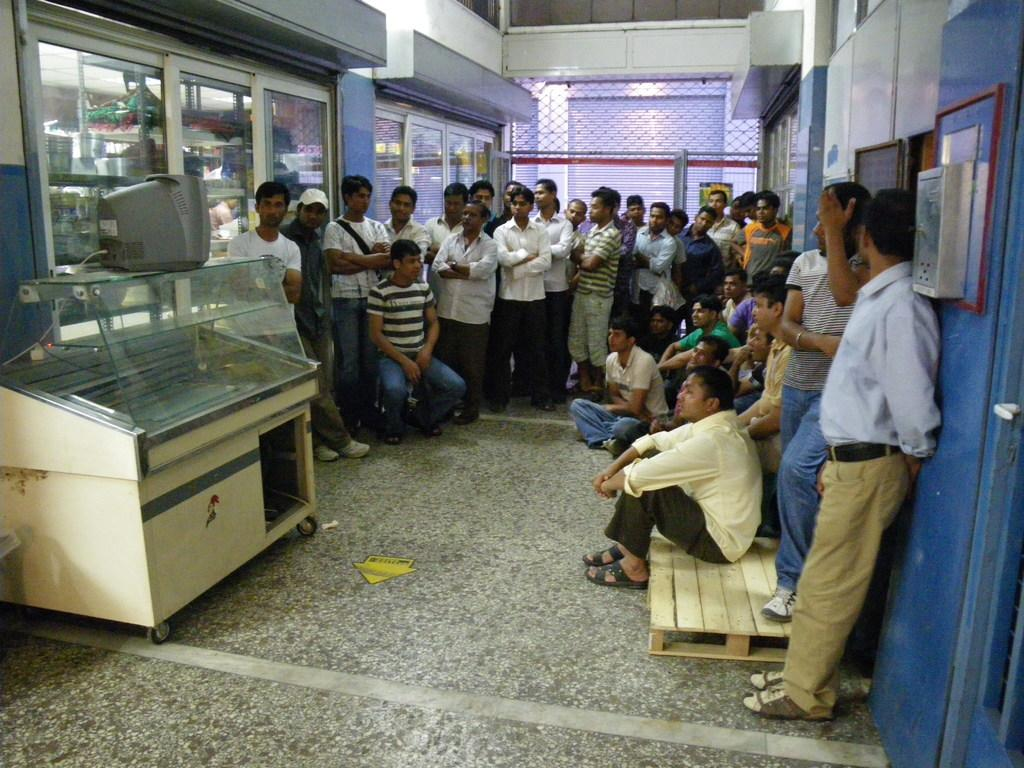Who or what is present in the image? There are people in the image. What can be seen on the left side of the image? There is a television on the left side of the image. What allows natural light to enter the room in the image? There are windows visible in the image. What type of furniture or storage is present in the image? There are objects on a shelf in the image. What type of pest can be seen crawling on the television in the image? There is no pest visible on the television in the image. How many women are present in the image? The provided facts do not specify the gender of the people in the image, so we cannot determine the number of women present. 